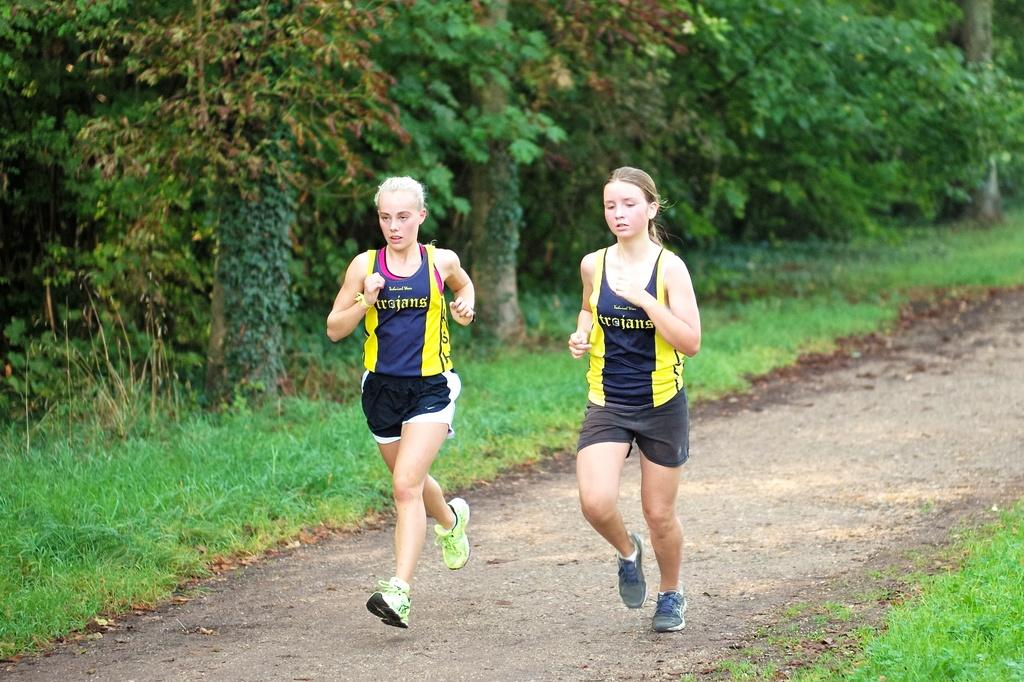How many women are in the image? There are two women in the image. What are the women doing in the image? The women are running on the ground in the image. What are the women wearing in the image? Both women are wearing the same t-shirt, shorts, and shoes in the image. What can be seen on the left side of the image? There are trees, plants, and grass on the left side of the image. How much glue is being used by the women in the image? There is no glue present in the image; the women are running and wearing athletic clothing. 